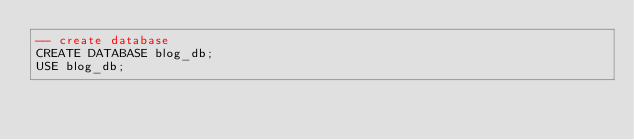<code> <loc_0><loc_0><loc_500><loc_500><_SQL_>-- create database
CREATE DATABASE blog_db;
USE blog_db;</code> 